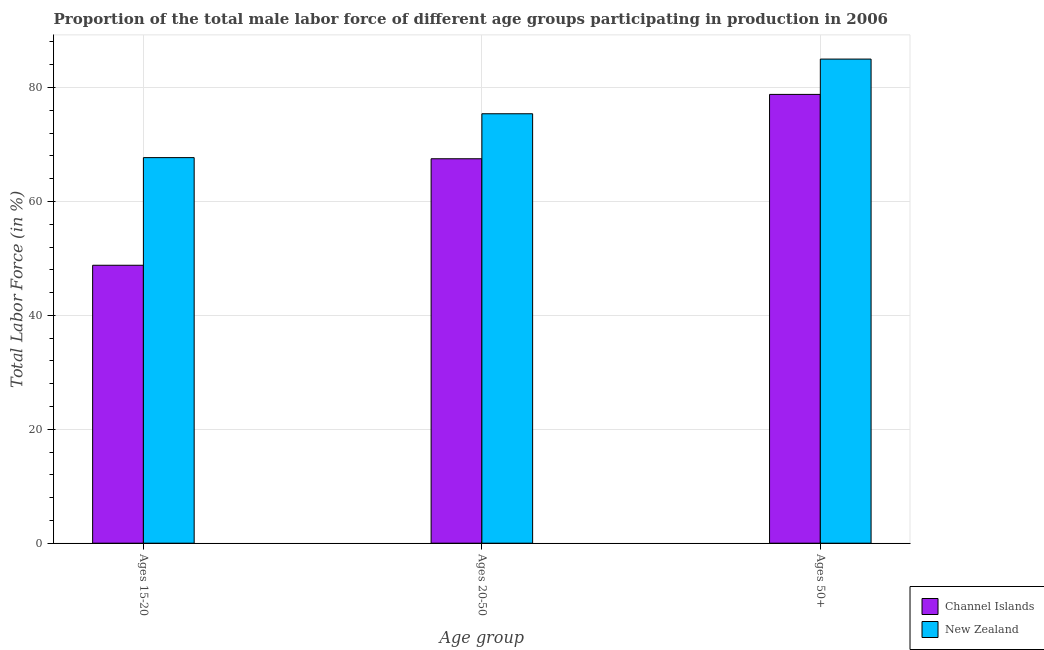How many groups of bars are there?
Offer a very short reply. 3. Are the number of bars per tick equal to the number of legend labels?
Provide a short and direct response. Yes. How many bars are there on the 3rd tick from the left?
Provide a succinct answer. 2. What is the label of the 2nd group of bars from the left?
Your answer should be very brief. Ages 20-50. Across all countries, what is the maximum percentage of male labor force within the age group 20-50?
Your response must be concise. 75.4. Across all countries, what is the minimum percentage of male labor force within the age group 15-20?
Your response must be concise. 48.8. In which country was the percentage of male labor force above age 50 maximum?
Your answer should be very brief. New Zealand. In which country was the percentage of male labor force above age 50 minimum?
Provide a succinct answer. Channel Islands. What is the total percentage of male labor force within the age group 20-50 in the graph?
Offer a very short reply. 142.9. What is the difference between the percentage of male labor force above age 50 in New Zealand and that in Channel Islands?
Provide a short and direct response. 6.2. What is the difference between the percentage of male labor force above age 50 in Channel Islands and the percentage of male labor force within the age group 15-20 in New Zealand?
Ensure brevity in your answer.  11.1. What is the average percentage of male labor force within the age group 20-50 per country?
Your response must be concise. 71.45. What is the difference between the percentage of male labor force above age 50 and percentage of male labor force within the age group 20-50 in Channel Islands?
Ensure brevity in your answer.  11.3. In how many countries, is the percentage of male labor force within the age group 20-50 greater than 80 %?
Your answer should be compact. 0. What is the ratio of the percentage of male labor force within the age group 20-50 in Channel Islands to that in New Zealand?
Make the answer very short. 0.9. Is the percentage of male labor force within the age group 15-20 in New Zealand less than that in Channel Islands?
Provide a succinct answer. No. What is the difference between the highest and the second highest percentage of male labor force within the age group 15-20?
Provide a succinct answer. 18.9. What is the difference between the highest and the lowest percentage of male labor force within the age group 20-50?
Ensure brevity in your answer.  7.9. In how many countries, is the percentage of male labor force within the age group 15-20 greater than the average percentage of male labor force within the age group 15-20 taken over all countries?
Your response must be concise. 1. What does the 1st bar from the left in Ages 50+ represents?
Give a very brief answer. Channel Islands. What does the 2nd bar from the right in Ages 50+ represents?
Make the answer very short. Channel Islands. Are all the bars in the graph horizontal?
Provide a short and direct response. No. What is the difference between two consecutive major ticks on the Y-axis?
Your answer should be very brief. 20. Does the graph contain any zero values?
Provide a succinct answer. No. Where does the legend appear in the graph?
Offer a very short reply. Bottom right. What is the title of the graph?
Offer a terse response. Proportion of the total male labor force of different age groups participating in production in 2006. Does "Cuba" appear as one of the legend labels in the graph?
Your answer should be compact. No. What is the label or title of the X-axis?
Keep it short and to the point. Age group. What is the Total Labor Force (in %) of Channel Islands in Ages 15-20?
Ensure brevity in your answer.  48.8. What is the Total Labor Force (in %) of New Zealand in Ages 15-20?
Provide a short and direct response. 67.7. What is the Total Labor Force (in %) in Channel Islands in Ages 20-50?
Offer a terse response. 67.5. What is the Total Labor Force (in %) of New Zealand in Ages 20-50?
Give a very brief answer. 75.4. What is the Total Labor Force (in %) of Channel Islands in Ages 50+?
Ensure brevity in your answer.  78.8. Across all Age group, what is the maximum Total Labor Force (in %) in Channel Islands?
Give a very brief answer. 78.8. Across all Age group, what is the maximum Total Labor Force (in %) in New Zealand?
Keep it short and to the point. 85. Across all Age group, what is the minimum Total Labor Force (in %) of Channel Islands?
Give a very brief answer. 48.8. Across all Age group, what is the minimum Total Labor Force (in %) in New Zealand?
Your answer should be compact. 67.7. What is the total Total Labor Force (in %) of Channel Islands in the graph?
Provide a short and direct response. 195.1. What is the total Total Labor Force (in %) in New Zealand in the graph?
Give a very brief answer. 228.1. What is the difference between the Total Labor Force (in %) of Channel Islands in Ages 15-20 and that in Ages 20-50?
Provide a succinct answer. -18.7. What is the difference between the Total Labor Force (in %) of New Zealand in Ages 15-20 and that in Ages 50+?
Ensure brevity in your answer.  -17.3. What is the difference between the Total Labor Force (in %) of New Zealand in Ages 20-50 and that in Ages 50+?
Provide a succinct answer. -9.6. What is the difference between the Total Labor Force (in %) of Channel Islands in Ages 15-20 and the Total Labor Force (in %) of New Zealand in Ages 20-50?
Your response must be concise. -26.6. What is the difference between the Total Labor Force (in %) in Channel Islands in Ages 15-20 and the Total Labor Force (in %) in New Zealand in Ages 50+?
Offer a very short reply. -36.2. What is the difference between the Total Labor Force (in %) of Channel Islands in Ages 20-50 and the Total Labor Force (in %) of New Zealand in Ages 50+?
Provide a short and direct response. -17.5. What is the average Total Labor Force (in %) of Channel Islands per Age group?
Provide a succinct answer. 65.03. What is the average Total Labor Force (in %) in New Zealand per Age group?
Offer a very short reply. 76.03. What is the difference between the Total Labor Force (in %) in Channel Islands and Total Labor Force (in %) in New Zealand in Ages 15-20?
Give a very brief answer. -18.9. What is the difference between the Total Labor Force (in %) of Channel Islands and Total Labor Force (in %) of New Zealand in Ages 20-50?
Ensure brevity in your answer.  -7.9. What is the difference between the Total Labor Force (in %) in Channel Islands and Total Labor Force (in %) in New Zealand in Ages 50+?
Provide a succinct answer. -6.2. What is the ratio of the Total Labor Force (in %) of Channel Islands in Ages 15-20 to that in Ages 20-50?
Provide a short and direct response. 0.72. What is the ratio of the Total Labor Force (in %) in New Zealand in Ages 15-20 to that in Ages 20-50?
Your answer should be very brief. 0.9. What is the ratio of the Total Labor Force (in %) in Channel Islands in Ages 15-20 to that in Ages 50+?
Ensure brevity in your answer.  0.62. What is the ratio of the Total Labor Force (in %) of New Zealand in Ages 15-20 to that in Ages 50+?
Offer a very short reply. 0.8. What is the ratio of the Total Labor Force (in %) in Channel Islands in Ages 20-50 to that in Ages 50+?
Provide a short and direct response. 0.86. What is the ratio of the Total Labor Force (in %) in New Zealand in Ages 20-50 to that in Ages 50+?
Offer a terse response. 0.89. What is the difference between the highest and the second highest Total Labor Force (in %) in New Zealand?
Ensure brevity in your answer.  9.6. What is the difference between the highest and the lowest Total Labor Force (in %) in Channel Islands?
Keep it short and to the point. 30. What is the difference between the highest and the lowest Total Labor Force (in %) in New Zealand?
Provide a short and direct response. 17.3. 